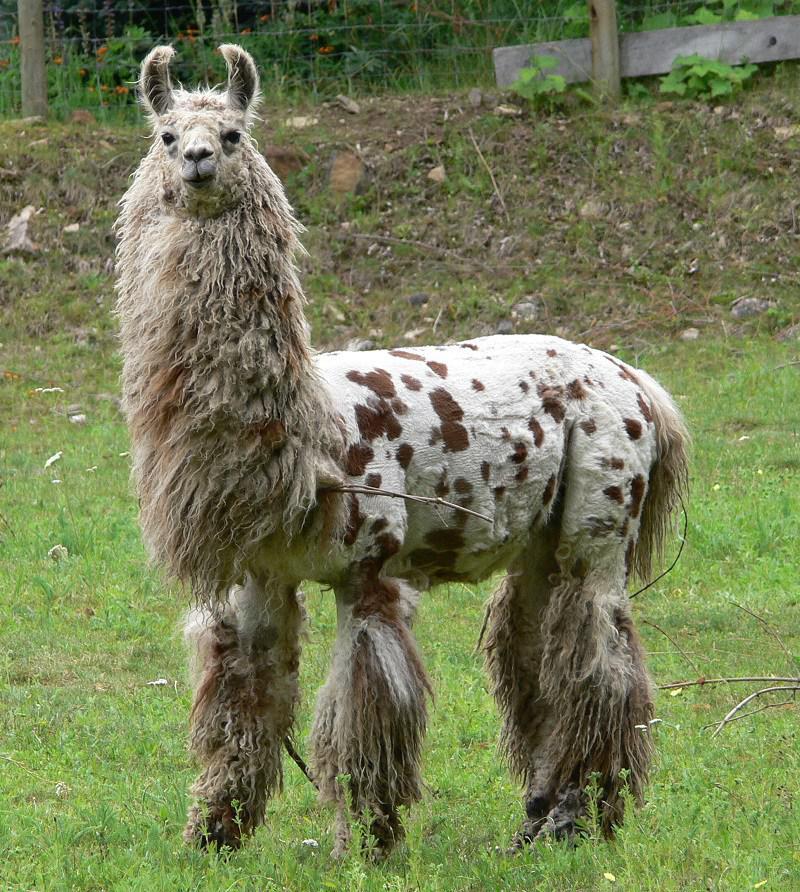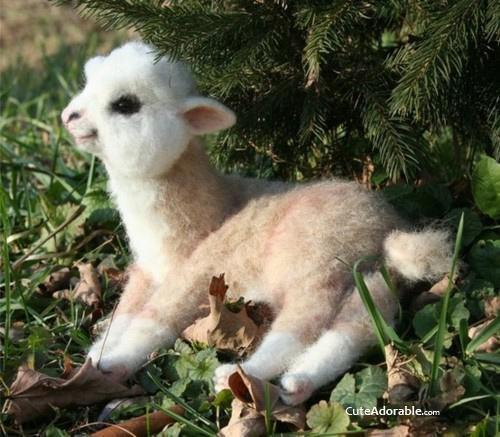The first image is the image on the left, the second image is the image on the right. Examine the images to the left and right. Is the description "There are two llamas in one image and one llama in the other." accurate? Answer yes or no. No. The first image is the image on the left, the second image is the image on the right. Analyze the images presented: Is the assertion "All llamas are lying on the ground, and at least one llama is lying with the side of its head on the ground." valid? Answer yes or no. No. 